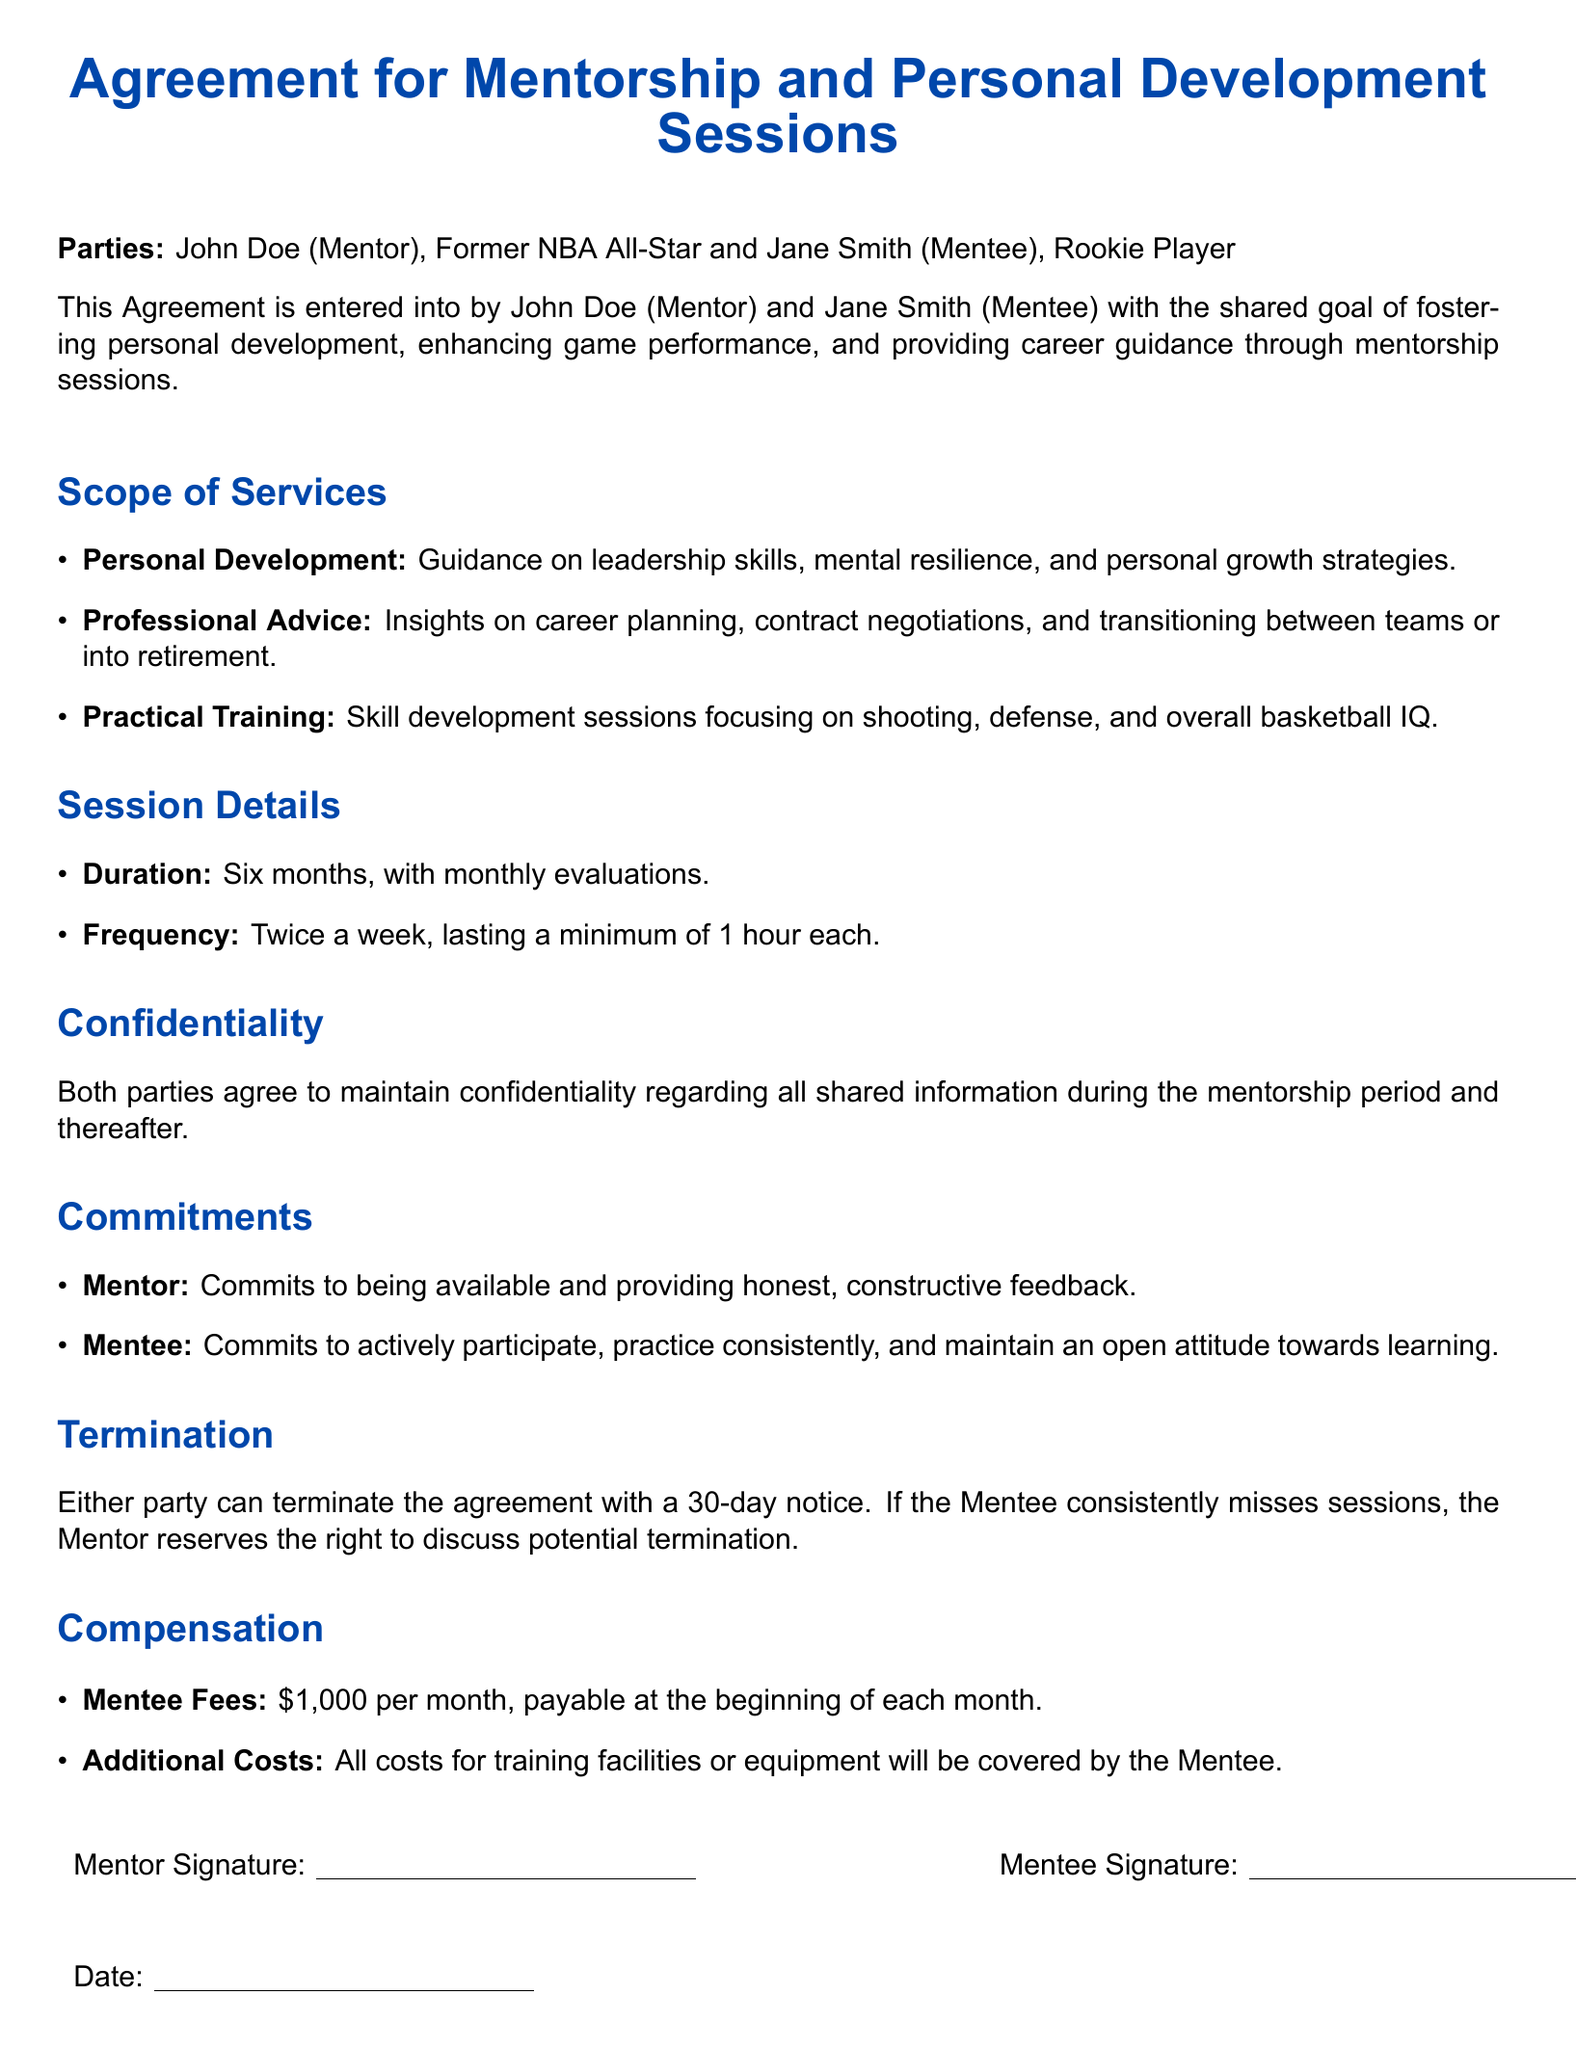What is the name of the mentor? The mentor is identified as John Doe in the document.
Answer: John Doe Who is the mentee? The mentee is referred to as Jane Smith in the document.
Answer: Jane Smith What is the duration of the mentorship agreement? The document specifies that the mentorship will last for six months.
Answer: Six months How often will the sessions occur? The frequency of the sessions is stated as twice a week.
Answer: Twice a week What is the monthly fee for the mentee? The document mentions that the mentee fees are set at one thousand dollars per month.
Answer: One thousand dollars What topics are covered under Personal Development? The document lists guidance on leadership skills, mental resilience, and personal growth strategies.
Answer: Leadership skills, mental resilience, personal growth strategies What is required for termination of the agreement? The agreement stipulates that either party can terminate it with a 30-day notice.
Answer: 30-day notice What commitment does the mentor make? The mentor commits to being available and providing honest, constructive feedback.
Answer: Honest, constructive feedback Who is responsible for additional costs? The document states that all additional costs for training facilities or equipment will be covered by the mentee.
Answer: Mentee 